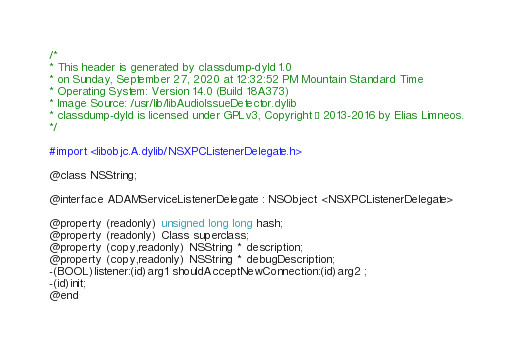<code> <loc_0><loc_0><loc_500><loc_500><_C_>/*
* This header is generated by classdump-dyld 1.0
* on Sunday, September 27, 2020 at 12:32:52 PM Mountain Standard Time
* Operating System: Version 14.0 (Build 18A373)
* Image Source: /usr/lib/libAudioIssueDetector.dylib
* classdump-dyld is licensed under GPLv3, Copyright © 2013-2016 by Elias Limneos.
*/

#import <libobjc.A.dylib/NSXPCListenerDelegate.h>

@class NSString;

@interface ADAMServiceListenerDelegate : NSObject <NSXPCListenerDelegate>

@property (readonly) unsigned long long hash; 
@property (readonly) Class superclass; 
@property (copy,readonly) NSString * description; 
@property (copy,readonly) NSString * debugDescription; 
-(BOOL)listener:(id)arg1 shouldAcceptNewConnection:(id)arg2 ;
-(id)init;
@end

</code> 